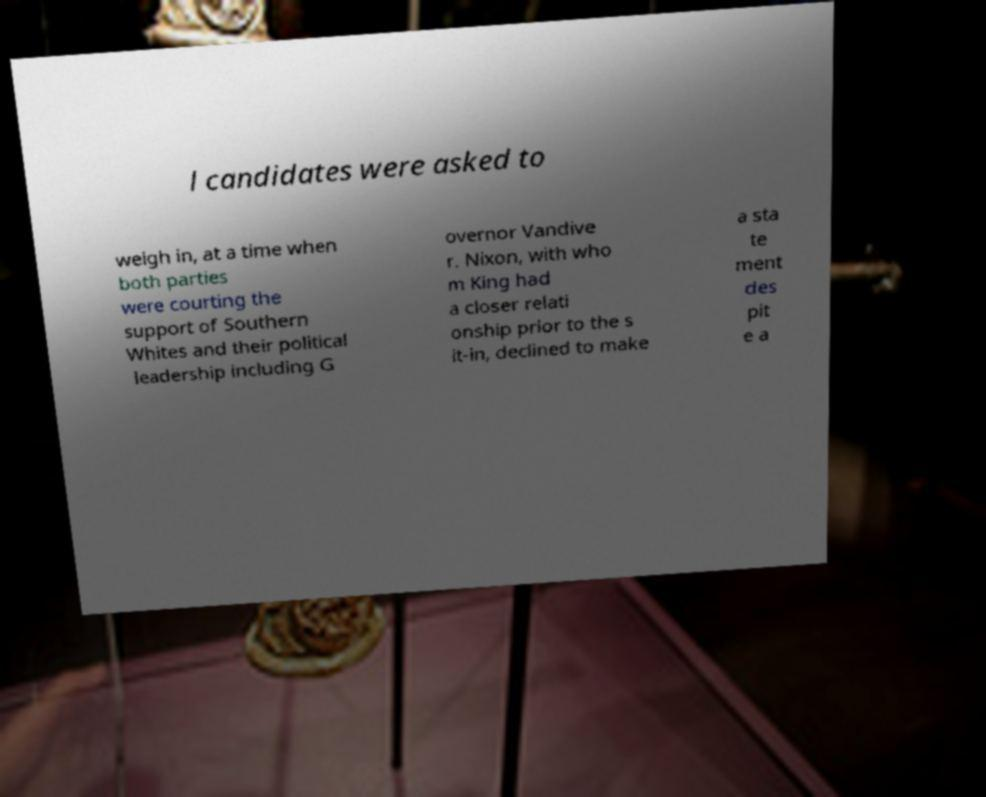Can you accurately transcribe the text from the provided image for me? l candidates were asked to weigh in, at a time when both parties were courting the support of Southern Whites and their political leadership including G overnor Vandive r. Nixon, with who m King had a closer relati onship prior to the s it-in, declined to make a sta te ment des pit e a 